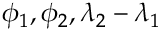<formula> <loc_0><loc_0><loc_500><loc_500>\phi _ { 1 } , \phi _ { 2 } , \lambda _ { 2 } - \lambda _ { 1 }</formula> 